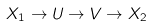<formula> <loc_0><loc_0><loc_500><loc_500>X _ { 1 } \rightarrow U & \rightarrow V \rightarrow X _ { 2 }</formula> 